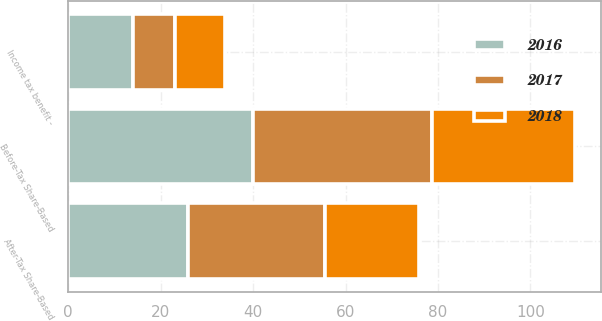Convert chart. <chart><loc_0><loc_0><loc_500><loc_500><stacked_bar_chart><ecel><fcel>Before-Tax Share-Based<fcel>Income tax benefit -<fcel>After-Tax Share-Based<nl><fcel>2017<fcel>38.8<fcel>9.1<fcel>29.7<nl><fcel>2016<fcel>39.9<fcel>14<fcel>25.9<nl><fcel>2018<fcel>31<fcel>10.8<fcel>20.2<nl></chart> 